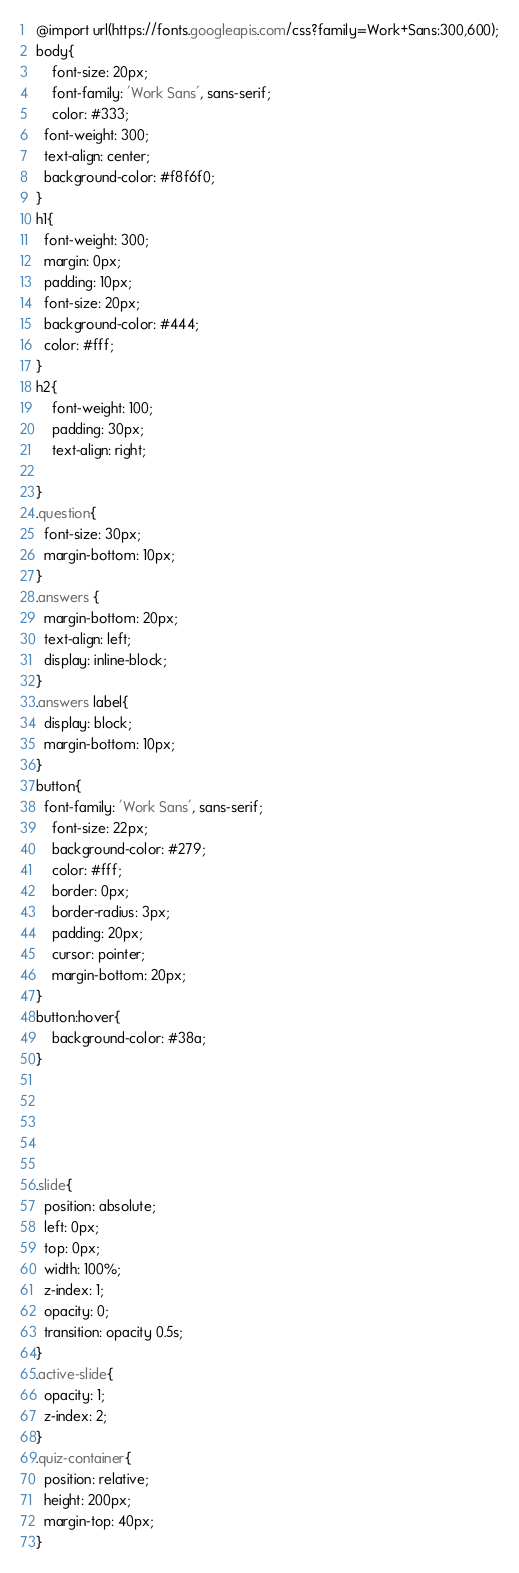<code> <loc_0><loc_0><loc_500><loc_500><_CSS_>@import url(https://fonts.googleapis.com/css?family=Work+Sans:300,600);
body{
	font-size: 20px;
	font-family: 'Work Sans', sans-serif;
	color: #333;
  font-weight: 300;
  text-align: center;
  background-color: #f8f6f0;
}
h1{
  font-weight: 300;
  margin: 0px;
  padding: 10px;
  font-size: 20px;
  background-color: #444;
  color: #fff;
}
h2{
    font-weight: 100;
    padding: 30px;
    text-align: right;
     
}
.question{
  font-size: 30px;
  margin-bottom: 10px;
}
.answers {
  margin-bottom: 20px;
  text-align: left;
  display: inline-block;
}
.answers label{
  display: block;
  margin-bottom: 10px;
}
button{
  font-family: 'Work Sans', sans-serif;
	font-size: 22px;
	background-color: #279;
	color: #fff;
	border: 0px;
	border-radius: 3px;
	padding: 20px;
	cursor: pointer;
	margin-bottom: 20px;
}
button:hover{
	background-color: #38a;
}





.slide{
  position: absolute;
  left: 0px;
  top: 0px;
  width: 100%;
  z-index: 1;
  opacity: 0;
  transition: opacity 0.5s;
}
.active-slide{
  opacity: 1;
  z-index: 2;
}
.quiz-container{
  position: relative;
  height: 200px;
  margin-top: 40px;
}
</code> 